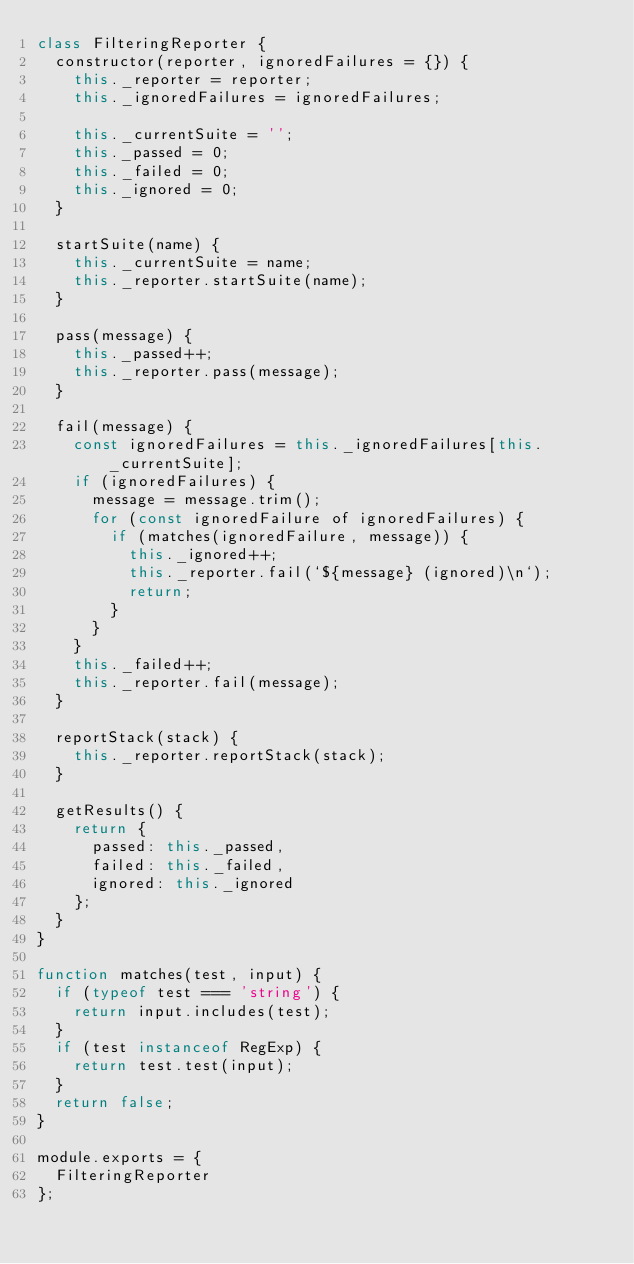<code> <loc_0><loc_0><loc_500><loc_500><_JavaScript_>class FilteringReporter {
  constructor(reporter, ignoredFailures = {}) {
    this._reporter = reporter;
    this._ignoredFailures = ignoredFailures;

    this._currentSuite = '';
    this._passed = 0;
    this._failed = 0;
    this._ignored = 0;
  }

  startSuite(name) {
    this._currentSuite = name;
    this._reporter.startSuite(name);
  }

  pass(message) {
    this._passed++;
    this._reporter.pass(message);
  }

  fail(message) {
    const ignoredFailures = this._ignoredFailures[this._currentSuite];
    if (ignoredFailures) {
      message = message.trim();
      for (const ignoredFailure of ignoredFailures) {
        if (matches(ignoredFailure, message)) {
          this._ignored++;
          this._reporter.fail(`${message} (ignored)\n`);
          return;
        }
      }
    }
    this._failed++;
    this._reporter.fail(message);
  }

  reportStack(stack) {
    this._reporter.reportStack(stack);
  }

  getResults() {
    return {
      passed: this._passed,
      failed: this._failed,
      ignored: this._ignored
    };
  }
}

function matches(test, input) {
  if (typeof test === 'string') {
    return input.includes(test);
  }
  if (test instanceof RegExp) {
    return test.test(input);
  }
  return false;
}

module.exports = {
  FilteringReporter
};
</code> 